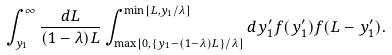<formula> <loc_0><loc_0><loc_500><loc_500>\int _ { y _ { 1 } } ^ { \infty } \frac { d L } { ( 1 - \lambda ) L } \int _ { \max [ 0 , \{ y _ { 1 } - ( 1 - \lambda ) L \} / \lambda ] } ^ { \min [ L , y _ { 1 } / \lambda ] } d y _ { 1 } ^ { \prime } f ( y _ { 1 } ^ { \prime } ) f ( L - y _ { 1 } ^ { \prime } ) .</formula> 